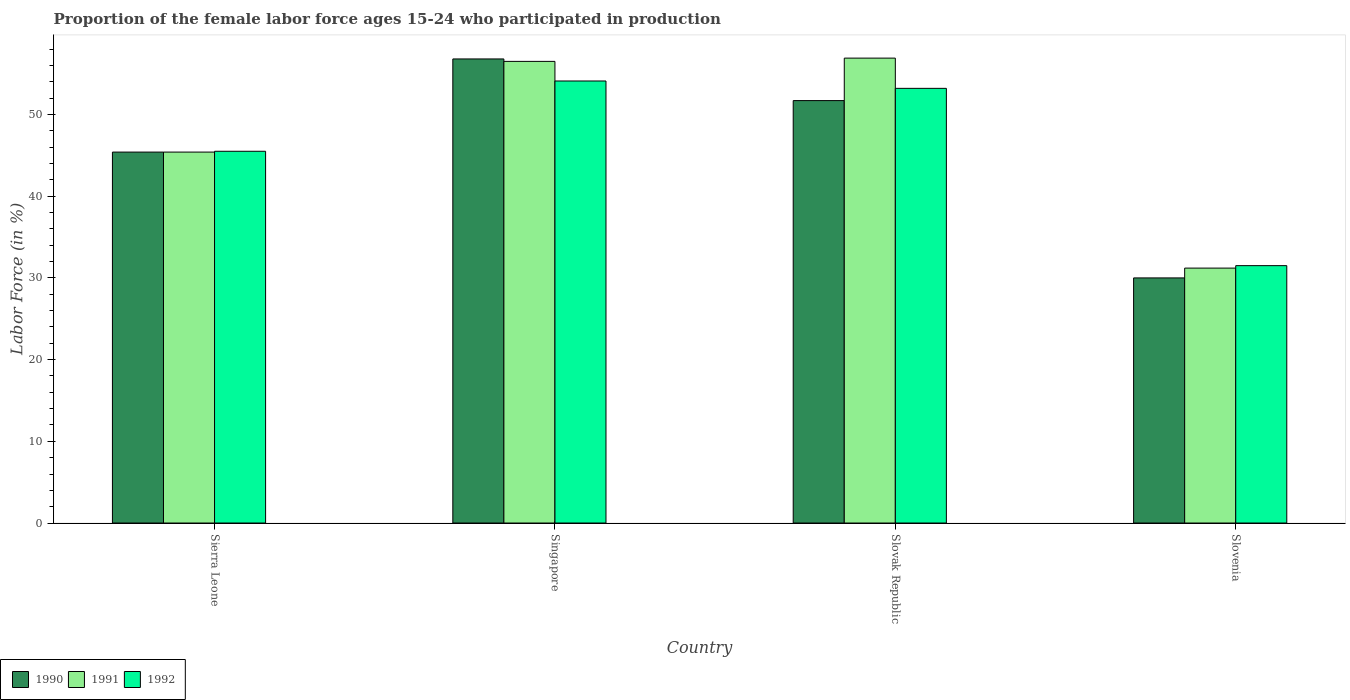How many different coloured bars are there?
Offer a terse response. 3. Are the number of bars per tick equal to the number of legend labels?
Give a very brief answer. Yes. How many bars are there on the 2nd tick from the left?
Ensure brevity in your answer.  3. What is the label of the 3rd group of bars from the left?
Keep it short and to the point. Slovak Republic. What is the proportion of the female labor force who participated in production in 1991 in Sierra Leone?
Offer a very short reply. 45.4. Across all countries, what is the maximum proportion of the female labor force who participated in production in 1992?
Your response must be concise. 54.1. Across all countries, what is the minimum proportion of the female labor force who participated in production in 1991?
Provide a succinct answer. 31.2. In which country was the proportion of the female labor force who participated in production in 1991 maximum?
Make the answer very short. Slovak Republic. In which country was the proportion of the female labor force who participated in production in 1990 minimum?
Give a very brief answer. Slovenia. What is the total proportion of the female labor force who participated in production in 1990 in the graph?
Make the answer very short. 183.9. What is the difference between the proportion of the female labor force who participated in production in 1990 in Sierra Leone and that in Slovak Republic?
Offer a very short reply. -6.3. What is the difference between the proportion of the female labor force who participated in production in 1990 in Slovenia and the proportion of the female labor force who participated in production in 1992 in Singapore?
Give a very brief answer. -24.1. What is the average proportion of the female labor force who participated in production in 1991 per country?
Ensure brevity in your answer.  47.5. What is the difference between the proportion of the female labor force who participated in production of/in 1991 and proportion of the female labor force who participated in production of/in 1992 in Slovak Republic?
Your response must be concise. 3.7. In how many countries, is the proportion of the female labor force who participated in production in 1990 greater than 50 %?
Offer a very short reply. 2. What is the ratio of the proportion of the female labor force who participated in production in 1991 in Sierra Leone to that in Singapore?
Your answer should be compact. 0.8. Is the proportion of the female labor force who participated in production in 1992 in Slovak Republic less than that in Slovenia?
Offer a terse response. No. What is the difference between the highest and the second highest proportion of the female labor force who participated in production in 1990?
Keep it short and to the point. 5.1. What is the difference between the highest and the lowest proportion of the female labor force who participated in production in 1992?
Provide a succinct answer. 22.6. What does the 3rd bar from the left in Singapore represents?
Your answer should be very brief. 1992. What does the 3rd bar from the right in Singapore represents?
Your response must be concise. 1990. Is it the case that in every country, the sum of the proportion of the female labor force who participated in production in 1990 and proportion of the female labor force who participated in production in 1992 is greater than the proportion of the female labor force who participated in production in 1991?
Keep it short and to the point. Yes. How many bars are there?
Provide a short and direct response. 12. How many countries are there in the graph?
Keep it short and to the point. 4. What is the difference between two consecutive major ticks on the Y-axis?
Ensure brevity in your answer.  10. Are the values on the major ticks of Y-axis written in scientific E-notation?
Provide a short and direct response. No. Does the graph contain grids?
Ensure brevity in your answer.  No. How are the legend labels stacked?
Offer a very short reply. Horizontal. What is the title of the graph?
Your response must be concise. Proportion of the female labor force ages 15-24 who participated in production. What is the label or title of the X-axis?
Provide a short and direct response. Country. What is the label or title of the Y-axis?
Keep it short and to the point. Labor Force (in %). What is the Labor Force (in %) in 1990 in Sierra Leone?
Your answer should be very brief. 45.4. What is the Labor Force (in %) in 1991 in Sierra Leone?
Ensure brevity in your answer.  45.4. What is the Labor Force (in %) of 1992 in Sierra Leone?
Give a very brief answer. 45.5. What is the Labor Force (in %) of 1990 in Singapore?
Offer a terse response. 56.8. What is the Labor Force (in %) in 1991 in Singapore?
Provide a short and direct response. 56.5. What is the Labor Force (in %) in 1992 in Singapore?
Offer a terse response. 54.1. What is the Labor Force (in %) in 1990 in Slovak Republic?
Offer a very short reply. 51.7. What is the Labor Force (in %) of 1991 in Slovak Republic?
Give a very brief answer. 56.9. What is the Labor Force (in %) in 1992 in Slovak Republic?
Your response must be concise. 53.2. What is the Labor Force (in %) of 1990 in Slovenia?
Your response must be concise. 30. What is the Labor Force (in %) of 1991 in Slovenia?
Make the answer very short. 31.2. What is the Labor Force (in %) in 1992 in Slovenia?
Make the answer very short. 31.5. Across all countries, what is the maximum Labor Force (in %) of 1990?
Offer a terse response. 56.8. Across all countries, what is the maximum Labor Force (in %) of 1991?
Provide a succinct answer. 56.9. Across all countries, what is the maximum Labor Force (in %) of 1992?
Provide a short and direct response. 54.1. Across all countries, what is the minimum Labor Force (in %) of 1991?
Give a very brief answer. 31.2. Across all countries, what is the minimum Labor Force (in %) of 1992?
Ensure brevity in your answer.  31.5. What is the total Labor Force (in %) of 1990 in the graph?
Your answer should be very brief. 183.9. What is the total Labor Force (in %) of 1991 in the graph?
Your answer should be compact. 190. What is the total Labor Force (in %) in 1992 in the graph?
Your answer should be compact. 184.3. What is the difference between the Labor Force (in %) of 1990 in Sierra Leone and that in Slovenia?
Offer a terse response. 15.4. What is the difference between the Labor Force (in %) of 1991 in Sierra Leone and that in Slovenia?
Offer a terse response. 14.2. What is the difference between the Labor Force (in %) of 1992 in Singapore and that in Slovak Republic?
Your answer should be very brief. 0.9. What is the difference between the Labor Force (in %) of 1990 in Singapore and that in Slovenia?
Offer a very short reply. 26.8. What is the difference between the Labor Force (in %) in 1991 in Singapore and that in Slovenia?
Your answer should be compact. 25.3. What is the difference between the Labor Force (in %) of 1992 in Singapore and that in Slovenia?
Provide a short and direct response. 22.6. What is the difference between the Labor Force (in %) of 1990 in Slovak Republic and that in Slovenia?
Offer a terse response. 21.7. What is the difference between the Labor Force (in %) in 1991 in Slovak Republic and that in Slovenia?
Provide a succinct answer. 25.7. What is the difference between the Labor Force (in %) of 1992 in Slovak Republic and that in Slovenia?
Make the answer very short. 21.7. What is the difference between the Labor Force (in %) of 1990 in Sierra Leone and the Labor Force (in %) of 1991 in Slovak Republic?
Keep it short and to the point. -11.5. What is the difference between the Labor Force (in %) in 1990 in Sierra Leone and the Labor Force (in %) in 1992 in Slovak Republic?
Offer a very short reply. -7.8. What is the difference between the Labor Force (in %) in 1990 in Sierra Leone and the Labor Force (in %) in 1991 in Slovenia?
Provide a short and direct response. 14.2. What is the difference between the Labor Force (in %) in 1990 in Singapore and the Labor Force (in %) in 1991 in Slovak Republic?
Keep it short and to the point. -0.1. What is the difference between the Labor Force (in %) of 1990 in Singapore and the Labor Force (in %) of 1992 in Slovak Republic?
Your response must be concise. 3.6. What is the difference between the Labor Force (in %) in 1990 in Singapore and the Labor Force (in %) in 1991 in Slovenia?
Your answer should be very brief. 25.6. What is the difference between the Labor Force (in %) in 1990 in Singapore and the Labor Force (in %) in 1992 in Slovenia?
Provide a short and direct response. 25.3. What is the difference between the Labor Force (in %) in 1990 in Slovak Republic and the Labor Force (in %) in 1992 in Slovenia?
Keep it short and to the point. 20.2. What is the difference between the Labor Force (in %) of 1991 in Slovak Republic and the Labor Force (in %) of 1992 in Slovenia?
Provide a succinct answer. 25.4. What is the average Labor Force (in %) in 1990 per country?
Your answer should be very brief. 45.98. What is the average Labor Force (in %) in 1991 per country?
Your response must be concise. 47.5. What is the average Labor Force (in %) in 1992 per country?
Give a very brief answer. 46.08. What is the difference between the Labor Force (in %) of 1991 and Labor Force (in %) of 1992 in Singapore?
Your answer should be very brief. 2.4. What is the difference between the Labor Force (in %) of 1990 and Labor Force (in %) of 1992 in Slovak Republic?
Ensure brevity in your answer.  -1.5. What is the difference between the Labor Force (in %) in 1990 and Labor Force (in %) in 1991 in Slovenia?
Offer a very short reply. -1.2. What is the ratio of the Labor Force (in %) of 1990 in Sierra Leone to that in Singapore?
Provide a succinct answer. 0.8. What is the ratio of the Labor Force (in %) in 1991 in Sierra Leone to that in Singapore?
Ensure brevity in your answer.  0.8. What is the ratio of the Labor Force (in %) of 1992 in Sierra Leone to that in Singapore?
Offer a terse response. 0.84. What is the ratio of the Labor Force (in %) in 1990 in Sierra Leone to that in Slovak Republic?
Your response must be concise. 0.88. What is the ratio of the Labor Force (in %) of 1991 in Sierra Leone to that in Slovak Republic?
Provide a short and direct response. 0.8. What is the ratio of the Labor Force (in %) in 1992 in Sierra Leone to that in Slovak Republic?
Give a very brief answer. 0.86. What is the ratio of the Labor Force (in %) in 1990 in Sierra Leone to that in Slovenia?
Your answer should be compact. 1.51. What is the ratio of the Labor Force (in %) of 1991 in Sierra Leone to that in Slovenia?
Offer a very short reply. 1.46. What is the ratio of the Labor Force (in %) of 1992 in Sierra Leone to that in Slovenia?
Keep it short and to the point. 1.44. What is the ratio of the Labor Force (in %) of 1990 in Singapore to that in Slovak Republic?
Provide a short and direct response. 1.1. What is the ratio of the Labor Force (in %) of 1991 in Singapore to that in Slovak Republic?
Make the answer very short. 0.99. What is the ratio of the Labor Force (in %) of 1992 in Singapore to that in Slovak Republic?
Your answer should be compact. 1.02. What is the ratio of the Labor Force (in %) of 1990 in Singapore to that in Slovenia?
Make the answer very short. 1.89. What is the ratio of the Labor Force (in %) in 1991 in Singapore to that in Slovenia?
Keep it short and to the point. 1.81. What is the ratio of the Labor Force (in %) of 1992 in Singapore to that in Slovenia?
Offer a terse response. 1.72. What is the ratio of the Labor Force (in %) in 1990 in Slovak Republic to that in Slovenia?
Offer a terse response. 1.72. What is the ratio of the Labor Force (in %) in 1991 in Slovak Republic to that in Slovenia?
Ensure brevity in your answer.  1.82. What is the ratio of the Labor Force (in %) of 1992 in Slovak Republic to that in Slovenia?
Provide a short and direct response. 1.69. What is the difference between the highest and the second highest Labor Force (in %) of 1991?
Offer a terse response. 0.4. What is the difference between the highest and the second highest Labor Force (in %) in 1992?
Your answer should be very brief. 0.9. What is the difference between the highest and the lowest Labor Force (in %) of 1990?
Provide a succinct answer. 26.8. What is the difference between the highest and the lowest Labor Force (in %) of 1991?
Your answer should be very brief. 25.7. What is the difference between the highest and the lowest Labor Force (in %) in 1992?
Your answer should be compact. 22.6. 